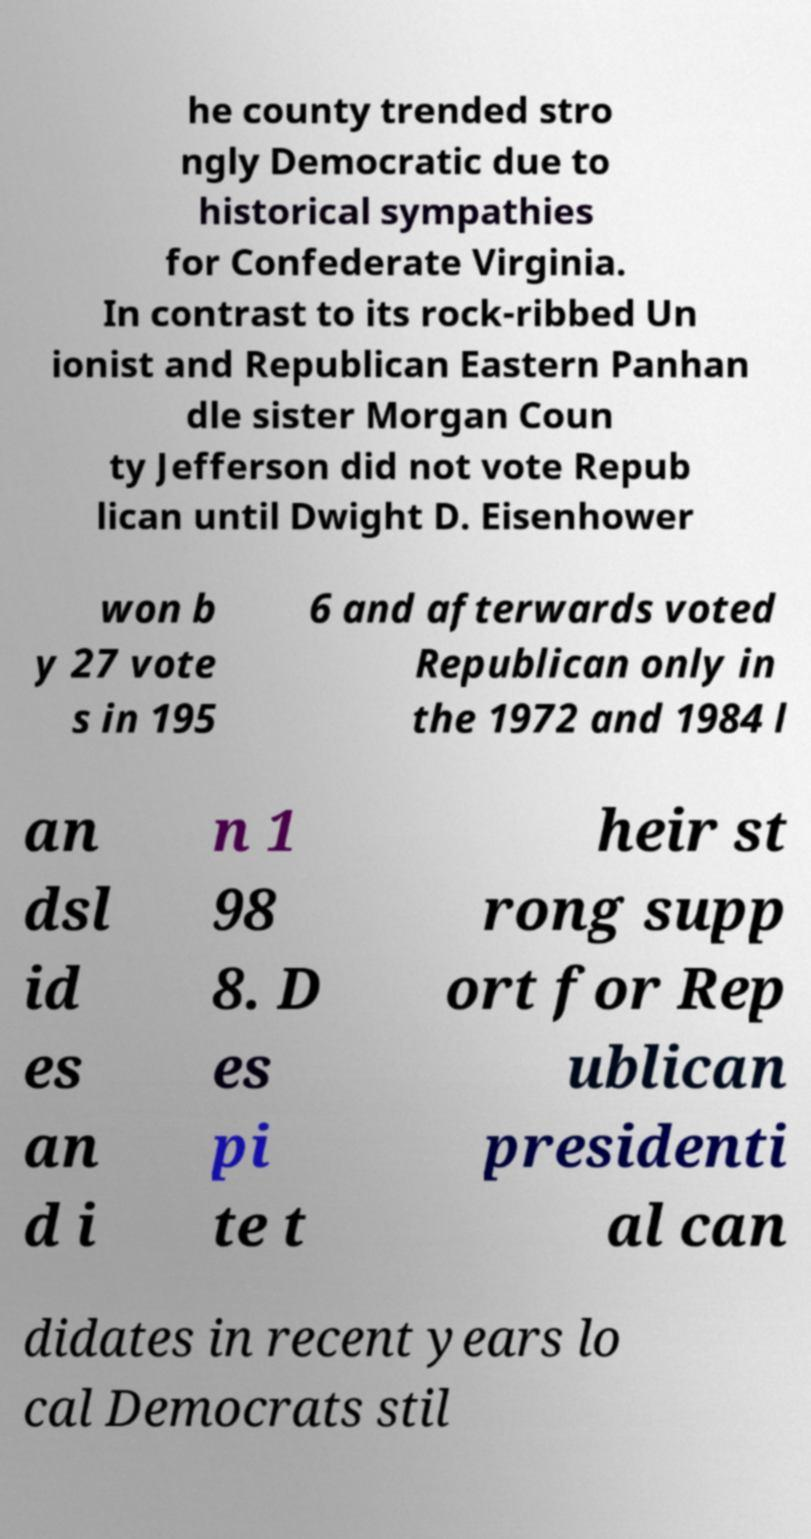Please read and relay the text visible in this image. What does it say? he county trended stro ngly Democratic due to historical sympathies for Confederate Virginia. In contrast to its rock-ribbed Un ionist and Republican Eastern Panhan dle sister Morgan Coun ty Jefferson did not vote Repub lican until Dwight D. Eisenhower won b y 27 vote s in 195 6 and afterwards voted Republican only in the 1972 and 1984 l an dsl id es an d i n 1 98 8. D es pi te t heir st rong supp ort for Rep ublican presidenti al can didates in recent years lo cal Democrats stil 